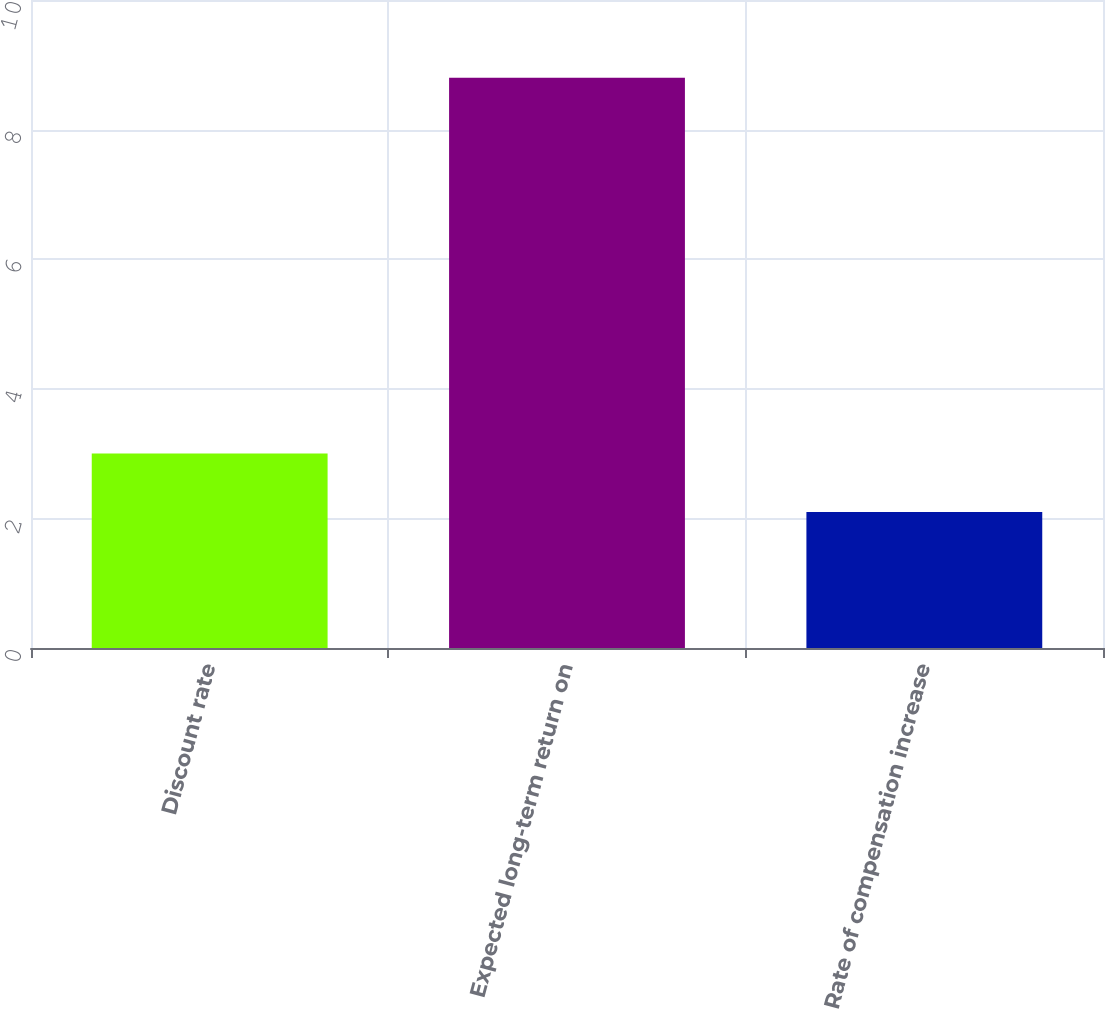Convert chart. <chart><loc_0><loc_0><loc_500><loc_500><bar_chart><fcel>Discount rate<fcel>Expected long-term return on<fcel>Rate of compensation increase<nl><fcel>3<fcel>8.8<fcel>2.1<nl></chart> 